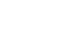<code> <loc_0><loc_0><loc_500><loc_500><_VisualBasic_>

</code> 